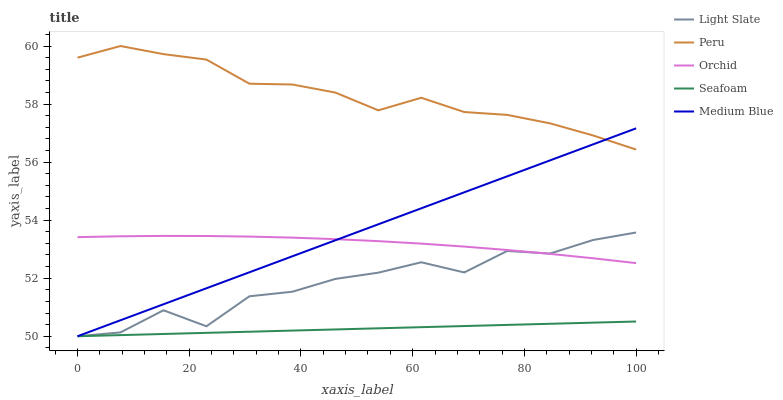Does Seafoam have the minimum area under the curve?
Answer yes or no. Yes. Does Peru have the maximum area under the curve?
Answer yes or no. Yes. Does Medium Blue have the minimum area under the curve?
Answer yes or no. No. Does Medium Blue have the maximum area under the curve?
Answer yes or no. No. Is Seafoam the smoothest?
Answer yes or no. Yes. Is Light Slate the roughest?
Answer yes or no. Yes. Is Medium Blue the smoothest?
Answer yes or no. No. Is Medium Blue the roughest?
Answer yes or no. No. Does Light Slate have the lowest value?
Answer yes or no. Yes. Does Peru have the lowest value?
Answer yes or no. No. Does Peru have the highest value?
Answer yes or no. Yes. Does Medium Blue have the highest value?
Answer yes or no. No. Is Orchid less than Peru?
Answer yes or no. Yes. Is Peru greater than Orchid?
Answer yes or no. Yes. Does Seafoam intersect Light Slate?
Answer yes or no. Yes. Is Seafoam less than Light Slate?
Answer yes or no. No. Is Seafoam greater than Light Slate?
Answer yes or no. No. Does Orchid intersect Peru?
Answer yes or no. No. 